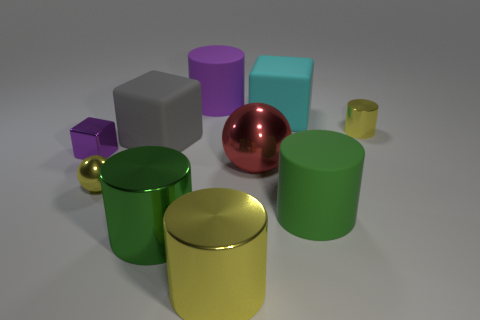Subtract all purple cylinders. How many cylinders are left? 4 Subtract all purple cylinders. How many cylinders are left? 4 Subtract all cyan cylinders. Subtract all green balls. How many cylinders are left? 5 Subtract all blocks. How many objects are left? 7 Add 4 cyan matte things. How many cyan matte things are left? 5 Add 8 tiny yellow cubes. How many tiny yellow cubes exist? 8 Subtract 1 green cylinders. How many objects are left? 9 Subtract all red things. Subtract all large matte objects. How many objects are left? 5 